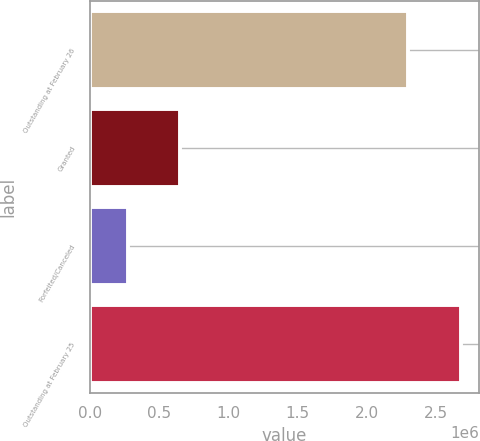Convert chart. <chart><loc_0><loc_0><loc_500><loc_500><bar_chart><fcel>Outstanding at February 26<fcel>Granted<fcel>Forfeited/Canceled<fcel>Outstanding at February 25<nl><fcel>2.297e+06<fcel>654000<fcel>273000<fcel>2.678e+06<nl></chart> 